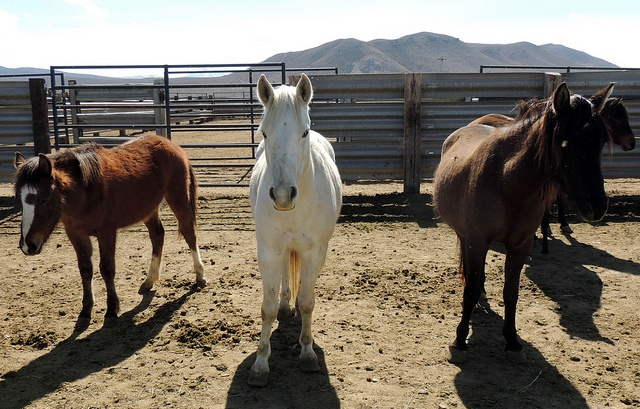Describe the objects in this image and their specific colors. I can see horse in lightblue, black, tan, and gray tones, horse in lightblue, black, maroon, gray, and tan tones, horse in lightblue and gray tones, and horse in lightblue, black, gray, and maroon tones in this image. 